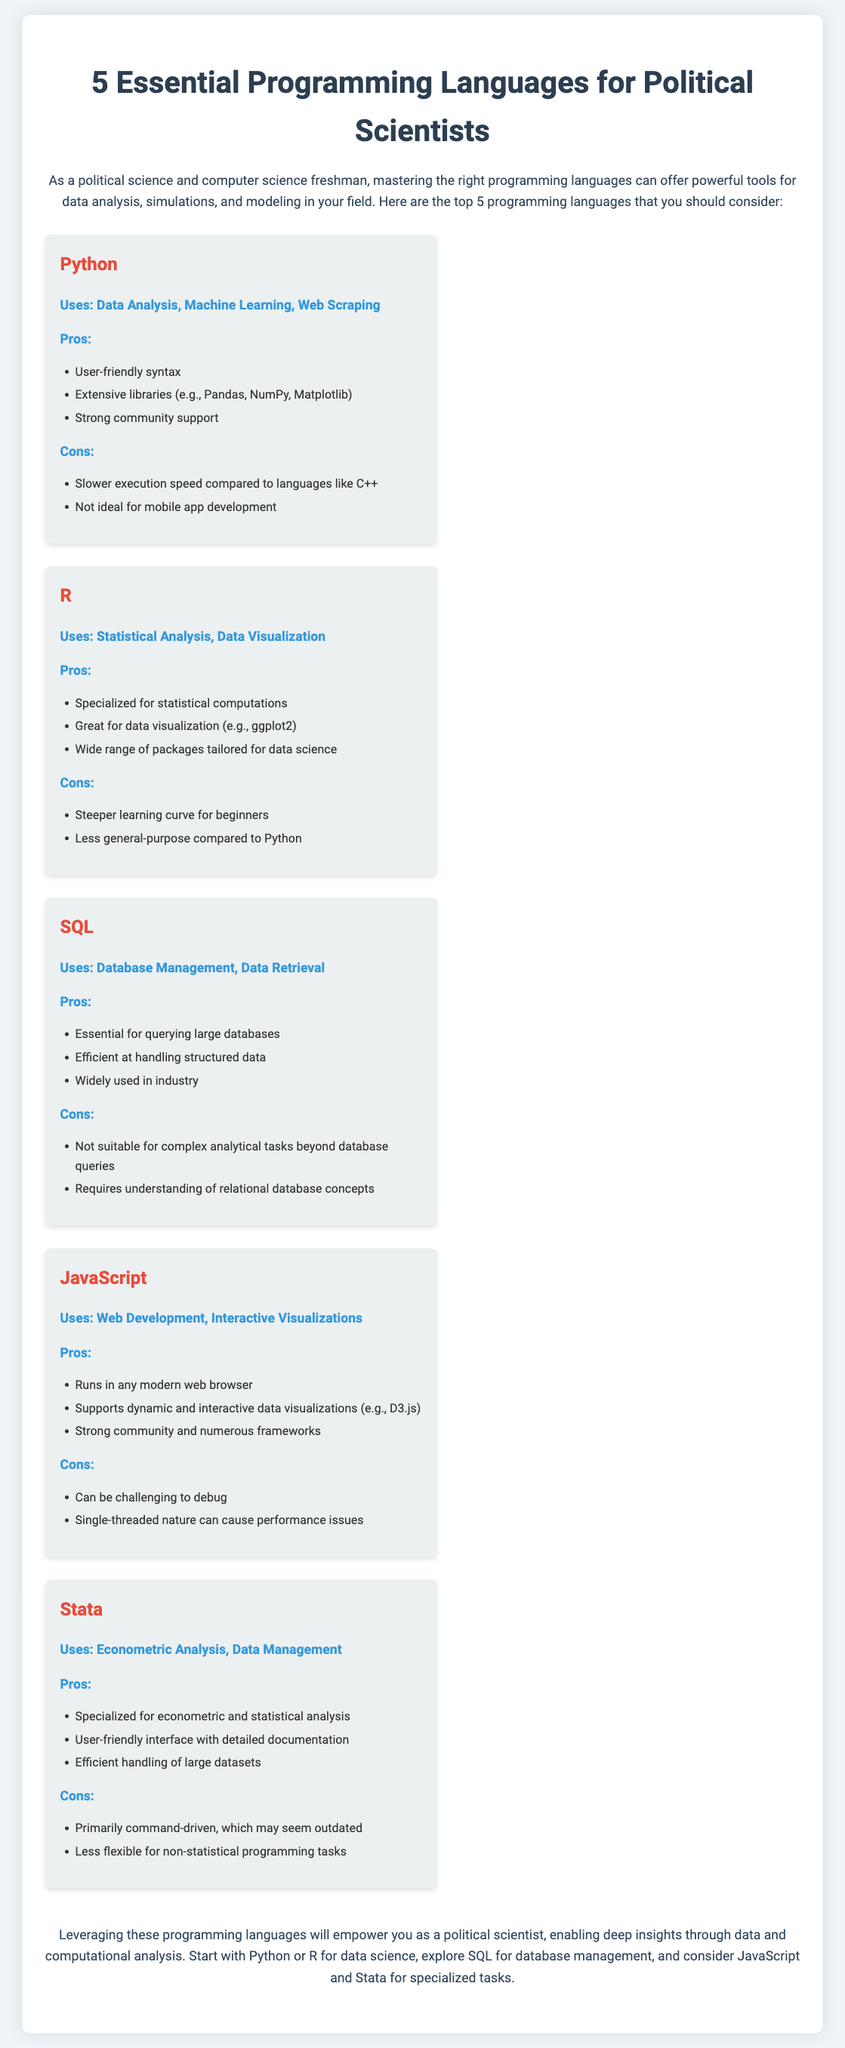What are the five programming languages mentioned? The document lists five essential programming languages that are relevant to political scientists, which are Python, R, SQL, JavaScript, and Stata.
Answer: Python, R, SQL, JavaScript, Stata What is the primary use of R? The document states that R is primarily used for statistical analysis and data visualization.
Answer: Statistical Analysis, Data Visualization What is a pro of using Python? The document lists several pros for Python, one of which is its user-friendly syntax.
Answer: User-friendly syntax Which language is specialized for econometric analysis? The document indicates that Stata is specialized for econometric analysis and data management.
Answer: Stata What is a downside of using SQL? According to the document, a con of using SQL is that it is not suitable for complex analytical tasks beyond database queries.
Answer: Not suitable for complex analytical tasks Which programming language is recommended for data visualization? The document suggests using R or JavaScript for data visualization, but specifically, R has great capabilities for data visualization.
Answer: R How many languages are focused on data analysis in the document? The document explicitly highlights Python and R as focused on data analysis.
Answer: Two What is the main focus of the document? The document focuses on presenting essential programming languages that can empower political scientists in their analysis and tasks.
Answer: Essential programming languages for political scientists 